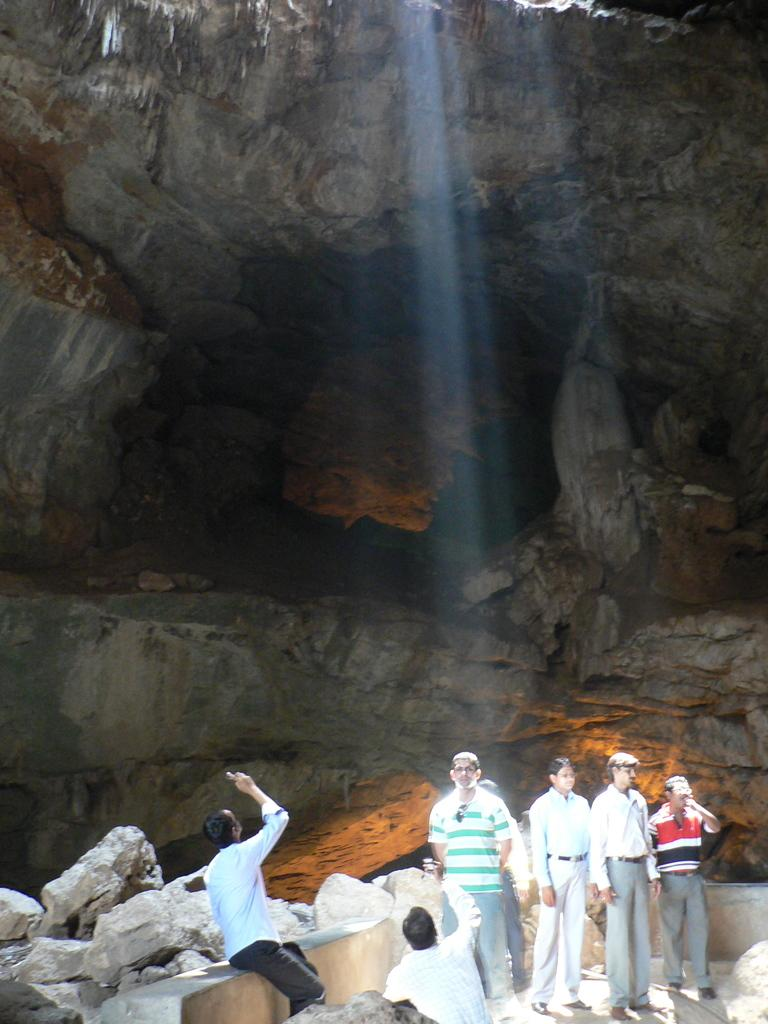How many people are in the image? There is a group of people in the image. What are the people in the image doing? The people are standing. Can you describe the person sitting in the image? There is someone sitting under a big rock in the image. What type of fish can be seen swimming in the afternoon in the image? There is no fish or reference to an afternoon in the image; it features a group of people standing and someone sitting under a big rock. 